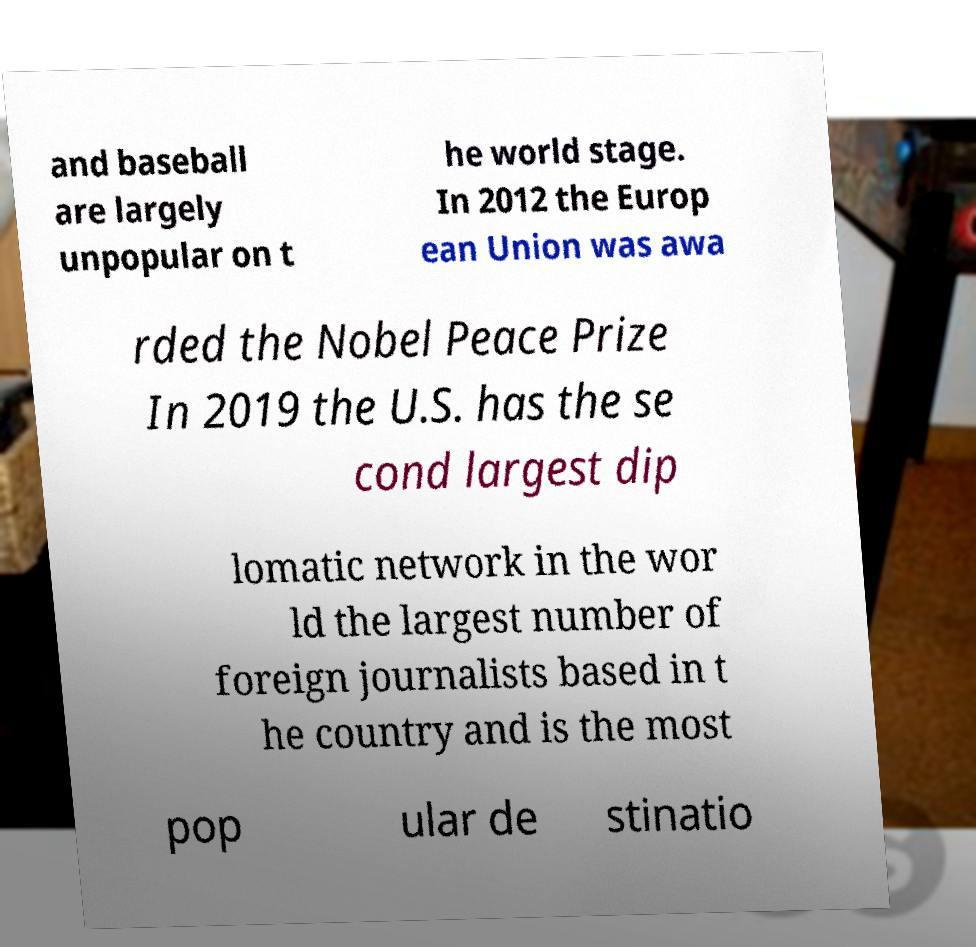There's text embedded in this image that I need extracted. Can you transcribe it verbatim? and baseball are largely unpopular on t he world stage. In 2012 the Europ ean Union was awa rded the Nobel Peace Prize In 2019 the U.S. has the se cond largest dip lomatic network in the wor ld the largest number of foreign journalists based in t he country and is the most pop ular de stinatio 